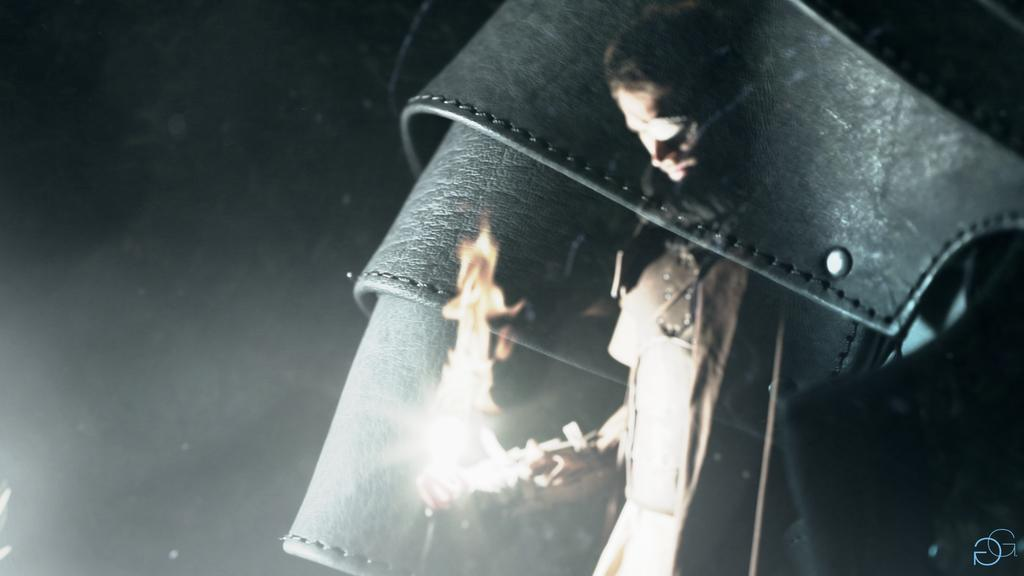What can be said about the nature of the image? The image is edited. What type of accessory is visible in the image? There is a leather belt in the image. What object is the man holding in the image? A man is holding a fire stick in the image. What theory can be applied to the jar in the image? There is no jar present in the image, so no theory can be applied to it. 